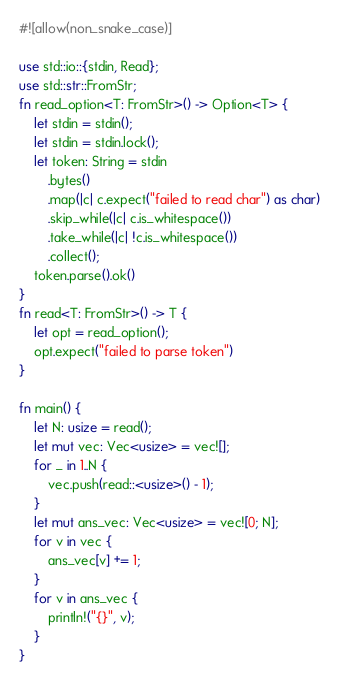Convert code to text. <code><loc_0><loc_0><loc_500><loc_500><_Rust_>#![allow(non_snake_case)]

use std::io::{stdin, Read};
use std::str::FromStr;
fn read_option<T: FromStr>() -> Option<T> {
    let stdin = stdin();
    let stdin = stdin.lock();
    let token: String = stdin
        .bytes()
        .map(|c| c.expect("failed to read char") as char)
        .skip_while(|c| c.is_whitespace())
        .take_while(|c| !c.is_whitespace())
        .collect();
    token.parse().ok()
}
fn read<T: FromStr>() -> T {
    let opt = read_option();
    opt.expect("failed to parse token")
}

fn main() {
    let N: usize = read();
    let mut vec: Vec<usize> = vec![];
    for _ in 1..N {
        vec.push(read::<usize>() - 1);
    }
    let mut ans_vec: Vec<usize> = vec![0; N];
    for v in vec {
        ans_vec[v] += 1;
    }
    for v in ans_vec {
        println!("{}", v);
    }
}
</code> 